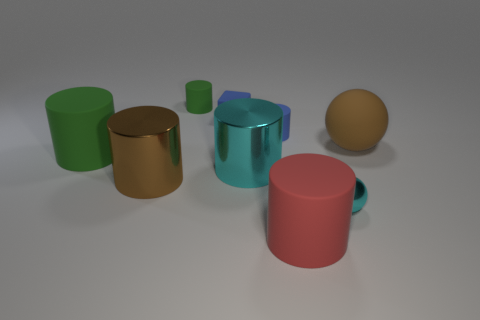What can you infer about the lighting in this scene? The shadows on the ground and the highlights on the objects suggest a single diffuse light source, perhaps overhead. This type of lighting creates soft shadows with gradual transitions from light to dark, which can be observed beneath and around the objects in this image. 